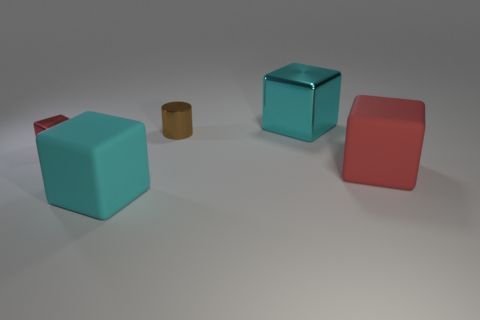Subtract all cyan blocks. How many were subtracted if there are1cyan blocks left? 1 Add 1 large rubber objects. How many objects exist? 6 Subtract all cylinders. How many objects are left? 4 Add 5 small metal blocks. How many small metal blocks are left? 6 Add 4 tiny brown metallic cylinders. How many tiny brown metallic cylinders exist? 5 Subtract 0 gray balls. How many objects are left? 5 Subtract all tiny balls. Subtract all shiny blocks. How many objects are left? 3 